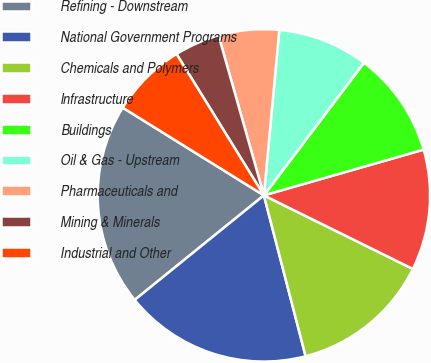Convert chart. <chart><loc_0><loc_0><loc_500><loc_500><pie_chart><fcel>Refining - Downstream<fcel>National Government Programs<fcel>Chemicals and Polymers<fcel>Infrastructure<fcel>Buildings<fcel>Oil & Gas - Upstream<fcel>Pharmaceuticals and<fcel>Mining & Minerals<fcel>Industrial and Other<nl><fcel>19.68%<fcel>18.21%<fcel>13.66%<fcel>11.74%<fcel>10.27%<fcel>8.81%<fcel>5.88%<fcel>4.41%<fcel>7.34%<nl></chart> 